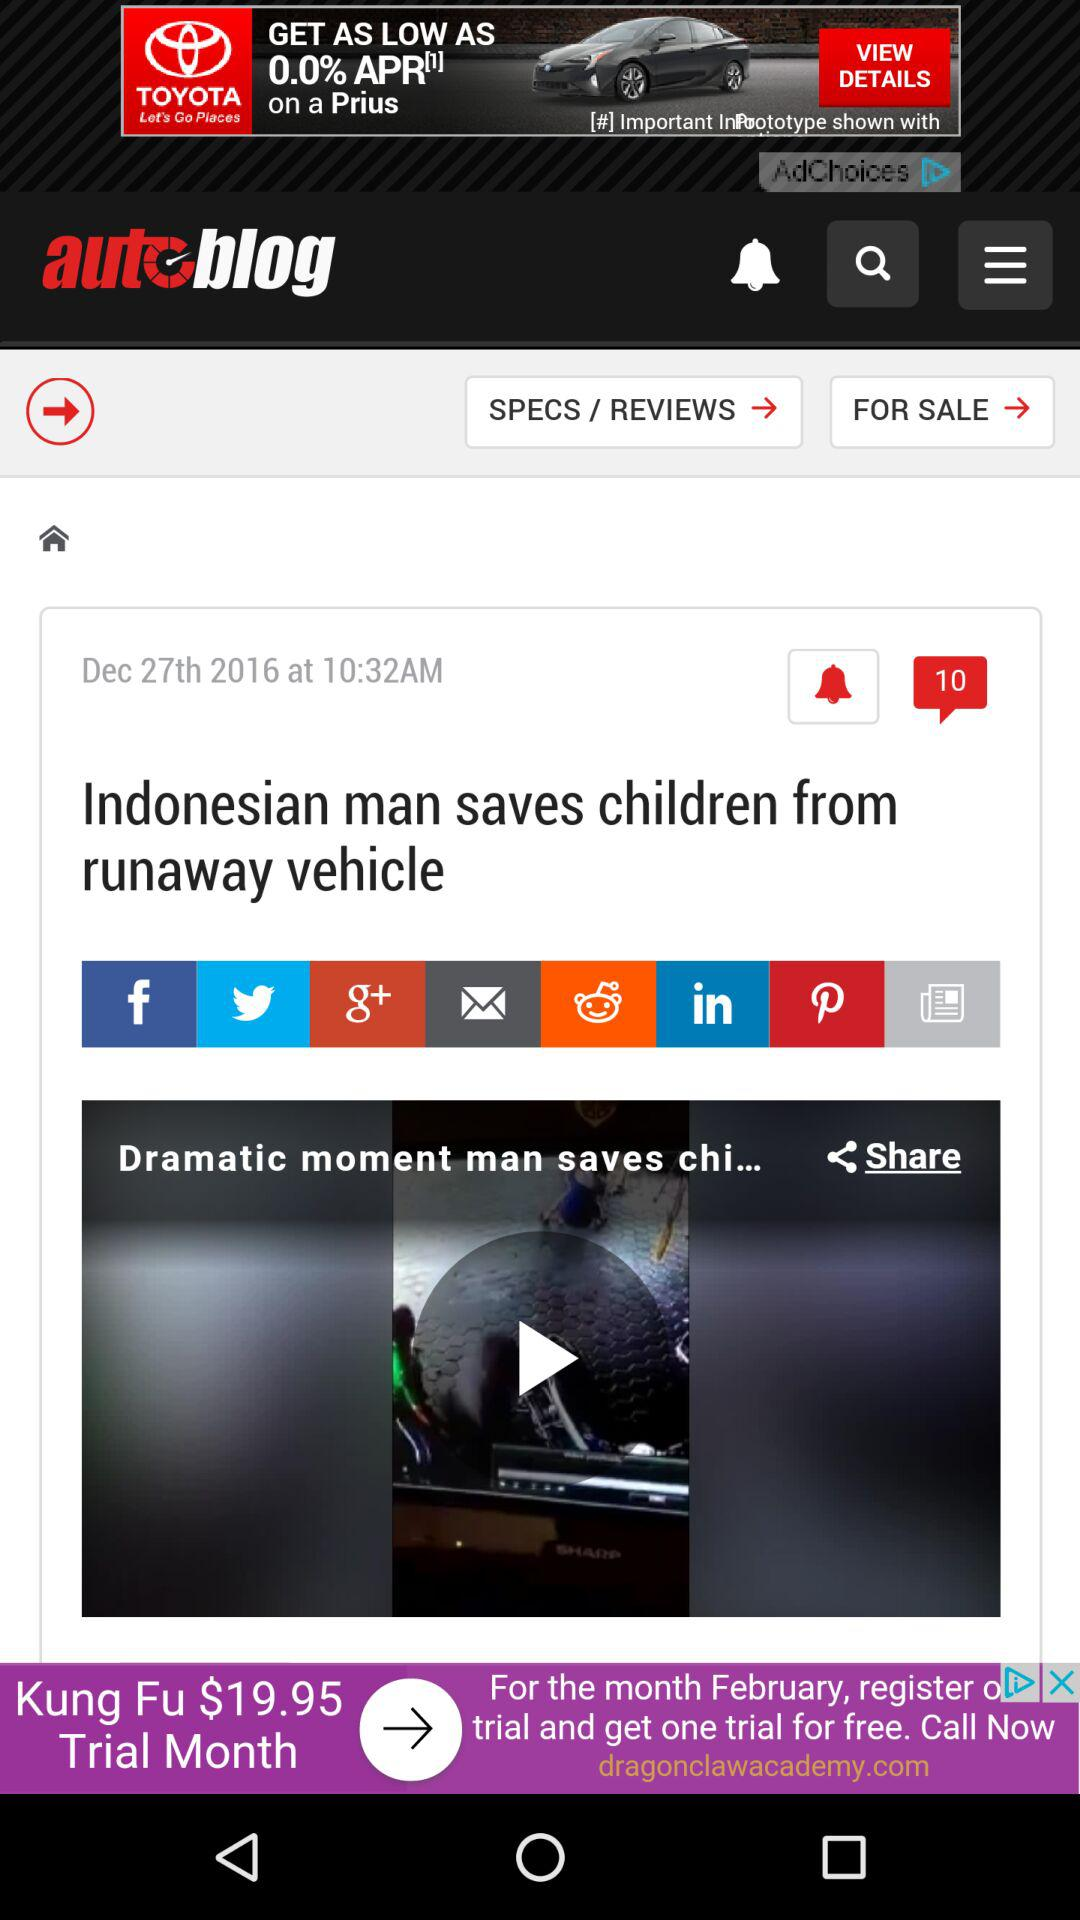What are the sharing options? The sharing options are "Facebook", "Twitter", "Google+", "Email", "Reddit", "LinkedIn", "Pinterest" and "Newsfeed". 